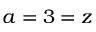Convert formula to latex. <formula><loc_0><loc_0><loc_500><loc_500>a = 3 = z</formula> 